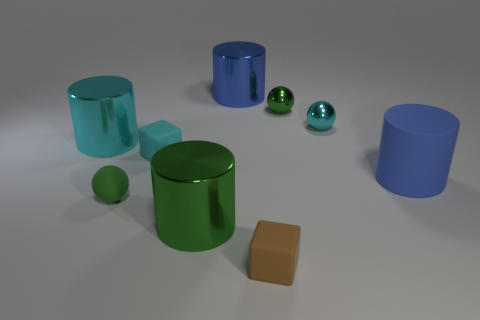There is a cyan thing that is to the left of the small rubber object that is behind the large cylinder right of the brown thing; what is its size?
Offer a very short reply. Large. Are there more big gray matte cubes than rubber balls?
Your answer should be very brief. No. Are the blue cylinder in front of the cyan metallic cylinder and the brown cube made of the same material?
Offer a terse response. Yes. Are there fewer blue things than cyan matte blocks?
Provide a short and direct response. No. Are there any big blue metal cylinders that are behind the big blue object that is behind the cyan ball that is behind the tiny green matte object?
Your response must be concise. No. Does the big blue shiny object that is on the right side of the green metal cylinder have the same shape as the big rubber object?
Make the answer very short. Yes. Is the number of balls behind the big blue rubber cylinder greater than the number of tiny shiny balls?
Offer a very short reply. No. There is a small cube to the left of the tiny brown object; is it the same color as the big rubber cylinder?
Offer a terse response. No. Is there anything else of the same color as the tiny rubber sphere?
Give a very brief answer. Yes. What color is the ball that is in front of the small cyan sphere that is behind the small cyan block right of the tiny green rubber sphere?
Your response must be concise. Green. 